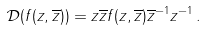Convert formula to latex. <formula><loc_0><loc_0><loc_500><loc_500>\mathcal { D } ( f ( z , \overline { z } ) ) = z \overline { z } f ( z , \overline { z } ) \overline { z } ^ { - 1 } z ^ { - 1 } \, .</formula> 